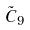Convert formula to latex. <formula><loc_0><loc_0><loc_500><loc_500>\tilde { C } _ { 9 }</formula> 